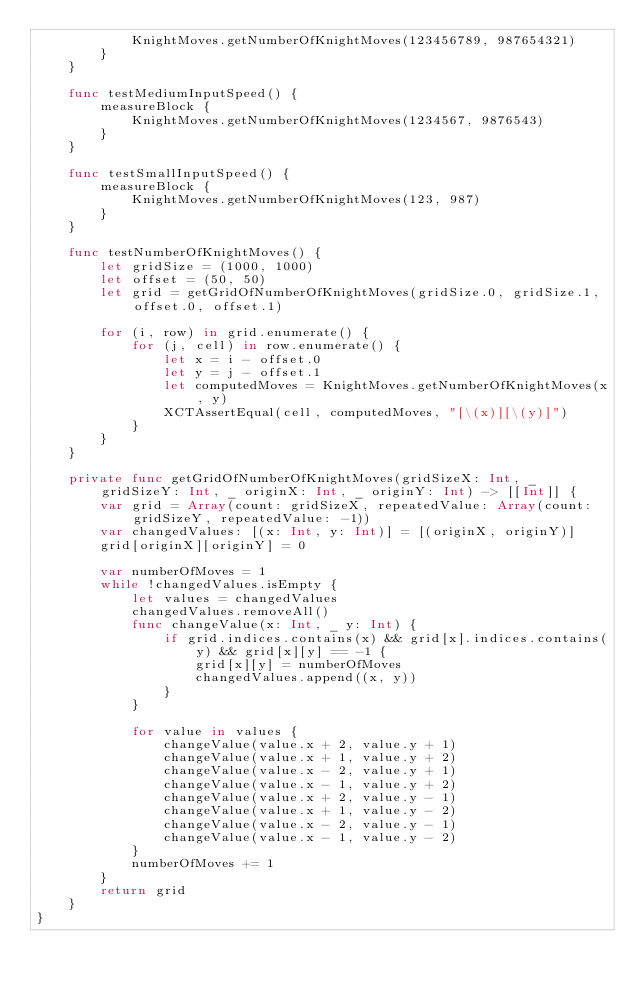Convert code to text. <code><loc_0><loc_0><loc_500><loc_500><_Swift_>            KnightMoves.getNumberOfKnightMoves(123456789, 987654321)
        }
    }
    
    func testMediumInputSpeed() {
        measureBlock {
            KnightMoves.getNumberOfKnightMoves(1234567, 9876543)
        }
    }
    
    func testSmallInputSpeed() {
        measureBlock {
            KnightMoves.getNumberOfKnightMoves(123, 987)
        }
    }
    
    func testNumberOfKnightMoves() {
        let gridSize = (1000, 1000)
        let offset = (50, 50)
        let grid = getGridOfNumberOfKnightMoves(gridSize.0, gridSize.1, offset.0, offset.1)
        
        for (i, row) in grid.enumerate() {
            for (j, cell) in row.enumerate() {
                let x = i - offset.0
                let y = j - offset.1
                let computedMoves = KnightMoves.getNumberOfKnightMoves(x, y)
                XCTAssertEqual(cell, computedMoves, "[\(x)][\(y)]")
            }
        }
    }
    
    private func getGridOfNumberOfKnightMoves(gridSizeX: Int, _ gridSizeY: Int, _ originX: Int, _ originY: Int) -> [[Int]] {
        var grid = Array(count: gridSizeX, repeatedValue: Array(count: gridSizeY, repeatedValue: -1))
        var changedValues: [(x: Int, y: Int)] = [(originX, originY)]
        grid[originX][originY] = 0

        var numberOfMoves = 1
        while !changedValues.isEmpty {
            let values = changedValues
            changedValues.removeAll()
            func changeValue(x: Int, _ y: Int) {
                if grid.indices.contains(x) && grid[x].indices.contains(y) && grid[x][y] == -1 {
                    grid[x][y] = numberOfMoves
                    changedValues.append((x, y))
                }
            }
            
            for value in values {
                changeValue(value.x + 2, value.y + 1)
                changeValue(value.x + 1, value.y + 2)
                changeValue(value.x - 2, value.y + 1)
                changeValue(value.x - 1, value.y + 2)
                changeValue(value.x + 2, value.y - 1)
                changeValue(value.x + 1, value.y - 2)
                changeValue(value.x - 2, value.y - 1)
                changeValue(value.x - 1, value.y - 2)
            }
            numberOfMoves += 1
        }
        return grid
    }
}
</code> 